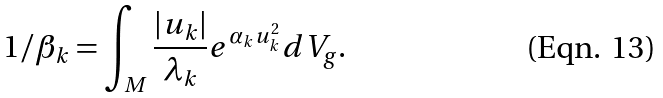Convert formula to latex. <formula><loc_0><loc_0><loc_500><loc_500>1 / \beta _ { k } = \int _ { M } \frac { | u _ { k } | } { \lambda _ { k } } e ^ { \alpha _ { k } u _ { k } ^ { 2 } } d V _ { g } .</formula> 